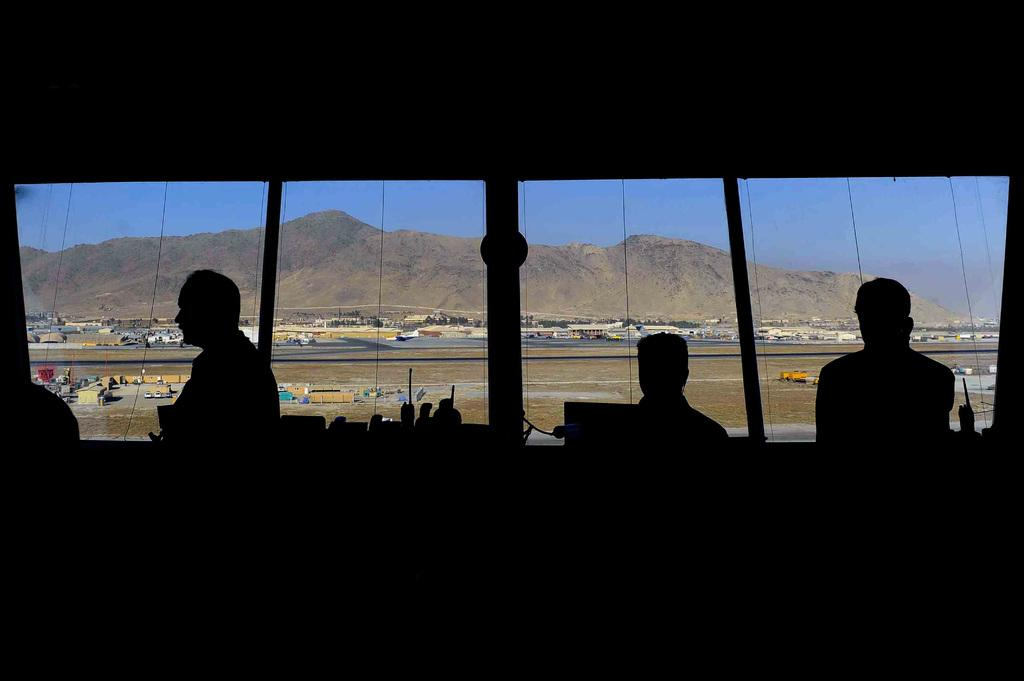What is the color or lighting condition at the bottom of the image? The bottom of the image is dark. What types of subjects are present in the image? There are people and vehicles in the image. Are there any objects related to serving or consuming food or beverages in the image? Yes, there are glasses in the image. What type of natural landmark is visible in the image? There is a mountain in the image. What is visible in the background of the image? The sky is visible in the background of the image. Can you tell me how many receipts are visible in the image? There are no receipts present in the image. What type of animal is sleeping on the mountain in the image? There is no animal sleeping on the mountain in the image, as the mountain is the only natural landmark mentioned in the facts. 